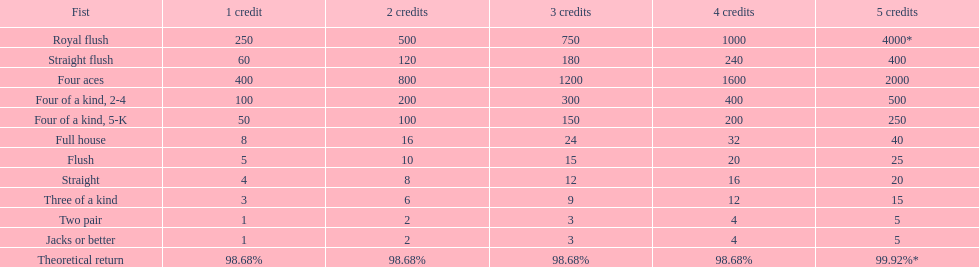At the greatest, what could a person gain for owning a full house? 40. 